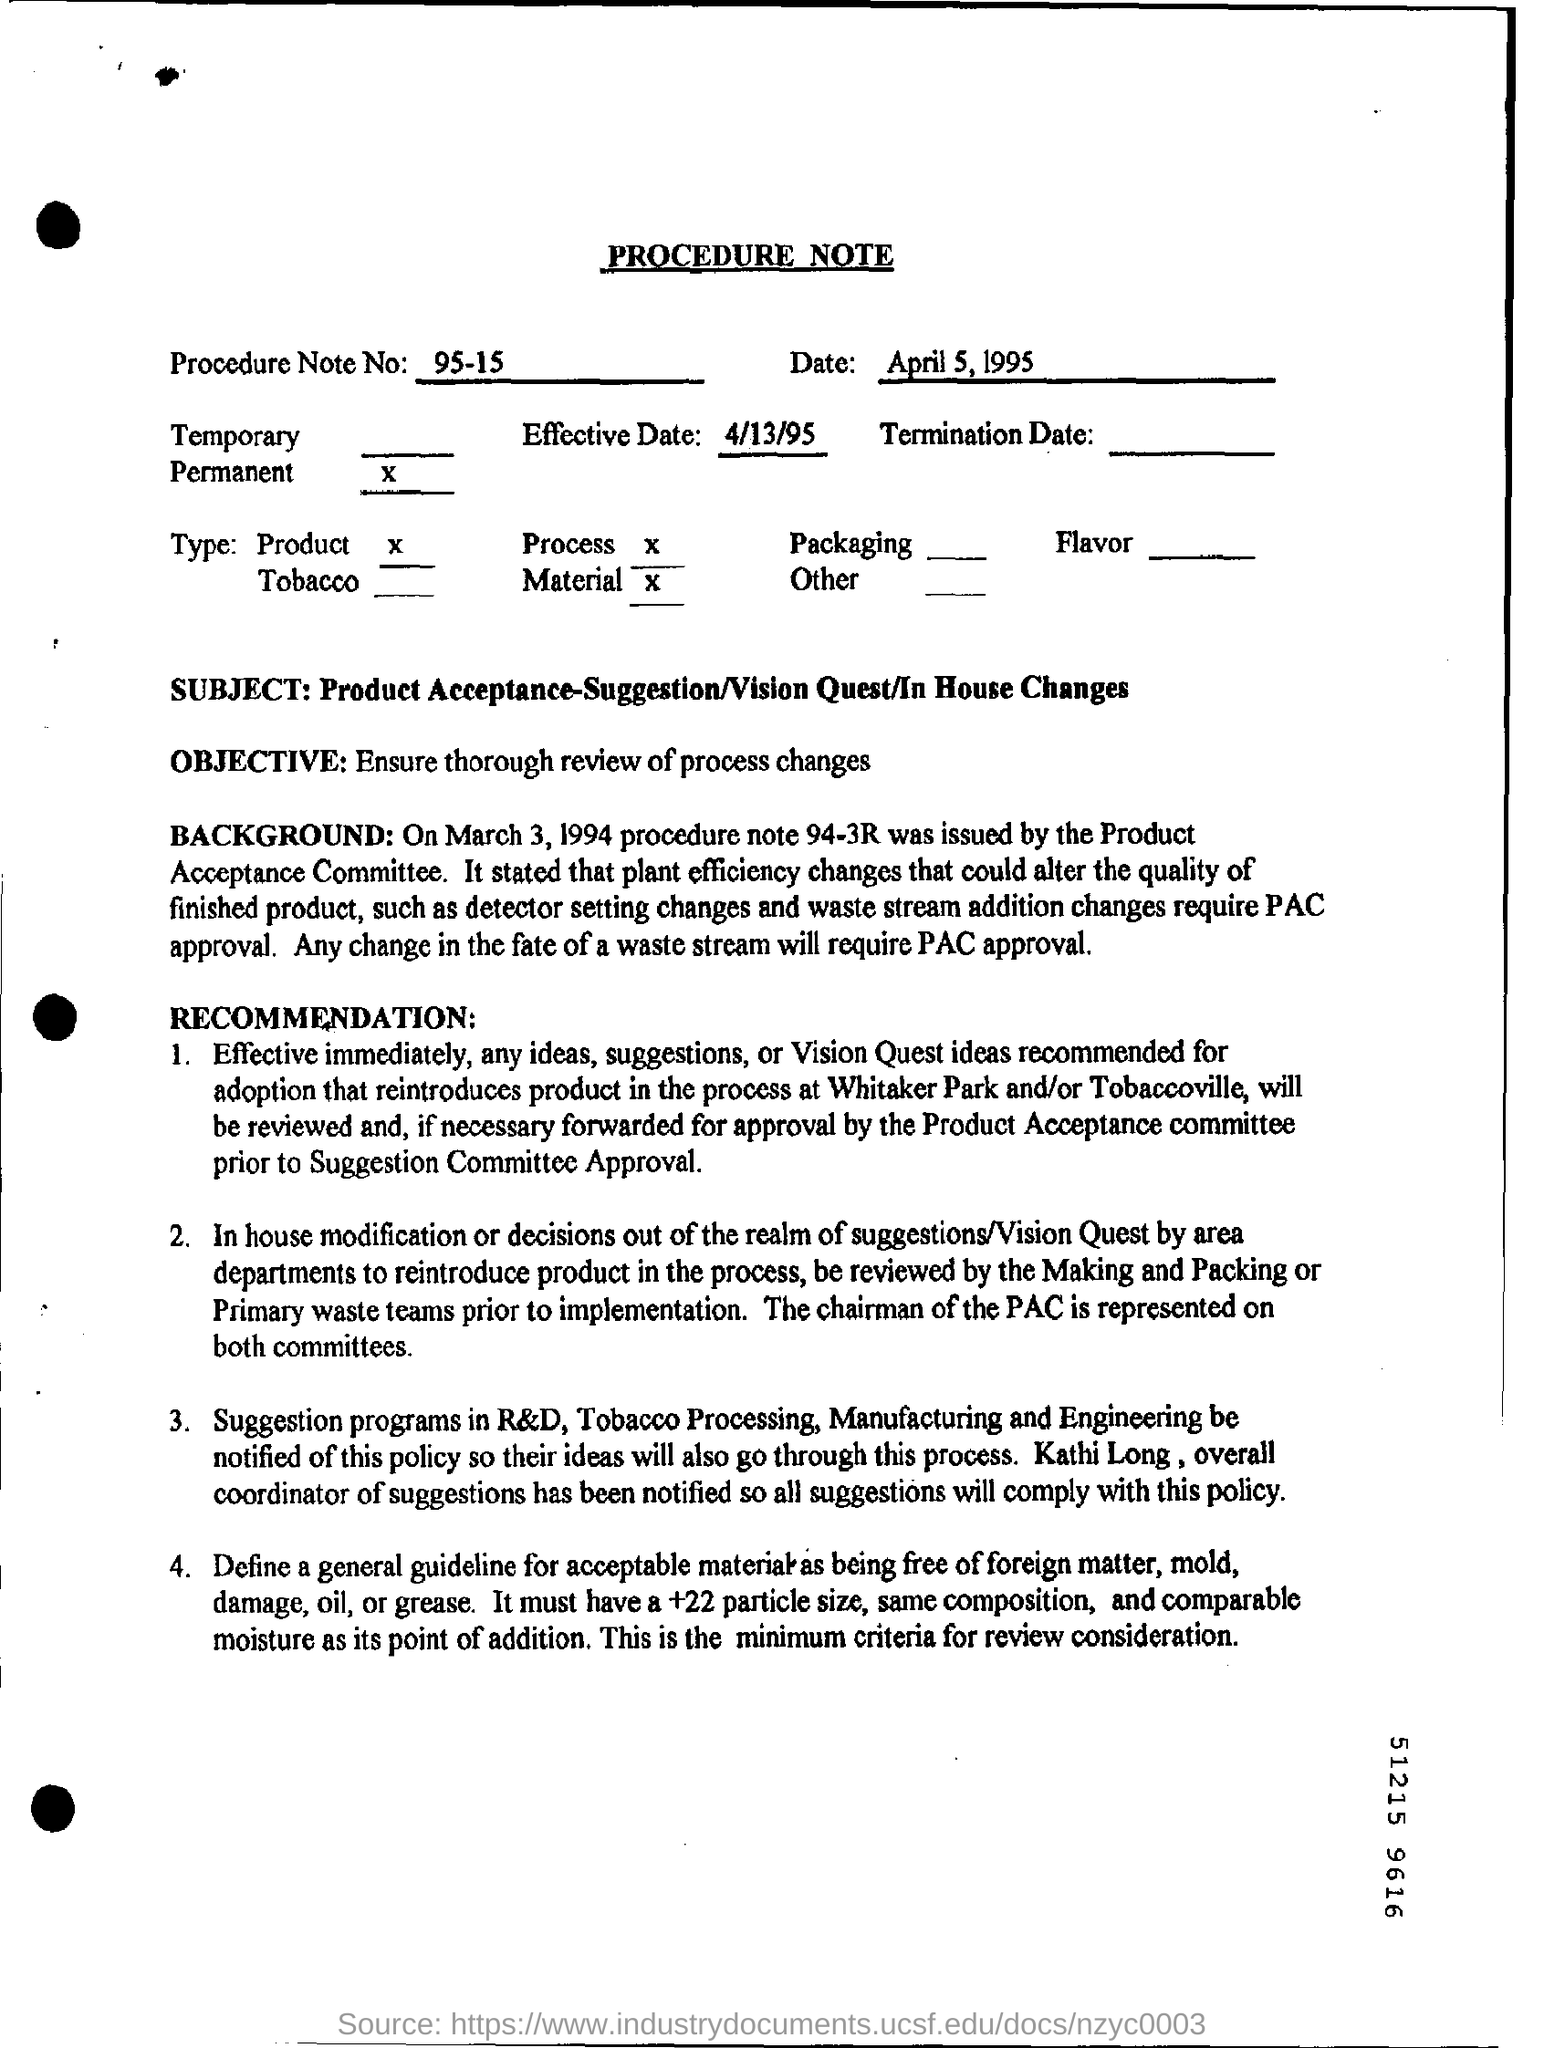Outline some significant characteristics in this image. Please provide the Procedure Note Number of the document in question, which is 95-15... This is a procedural note. The subject of this procedure note is the acceptance of a product, which involves considering suggestions or visions and making any necessary changes within the company. In order to make any changes to the fate of a waste stream, PAC approval is required. The effective date mentioned in this document is April 13, 1995. 